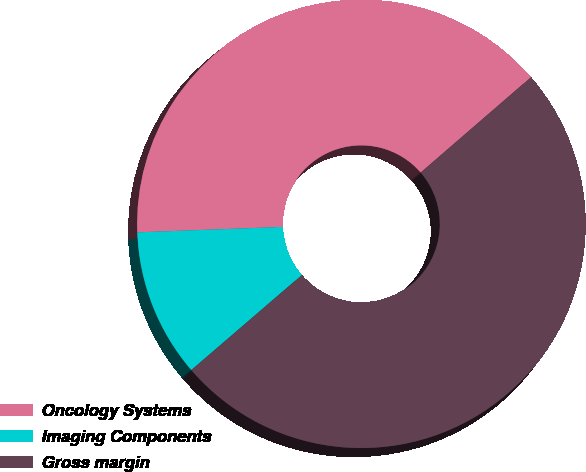Convert chart to OTSL. <chart><loc_0><loc_0><loc_500><loc_500><pie_chart><fcel>Oncology Systems<fcel>Imaging Components<fcel>Gross margin<nl><fcel>39.25%<fcel>10.71%<fcel>50.04%<nl></chart> 